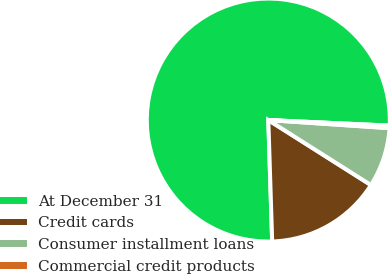Convert chart to OTSL. <chart><loc_0><loc_0><loc_500><loc_500><pie_chart><fcel>At December 31<fcel>Credit cards<fcel>Consumer installment loans<fcel>Commercial credit products<nl><fcel>76.24%<fcel>15.51%<fcel>7.92%<fcel>0.33%<nl></chart> 